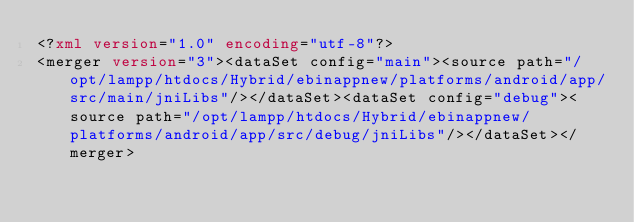Convert code to text. <code><loc_0><loc_0><loc_500><loc_500><_XML_><?xml version="1.0" encoding="utf-8"?>
<merger version="3"><dataSet config="main"><source path="/opt/lampp/htdocs/Hybrid/ebinappnew/platforms/android/app/src/main/jniLibs"/></dataSet><dataSet config="debug"><source path="/opt/lampp/htdocs/Hybrid/ebinappnew/platforms/android/app/src/debug/jniLibs"/></dataSet></merger></code> 